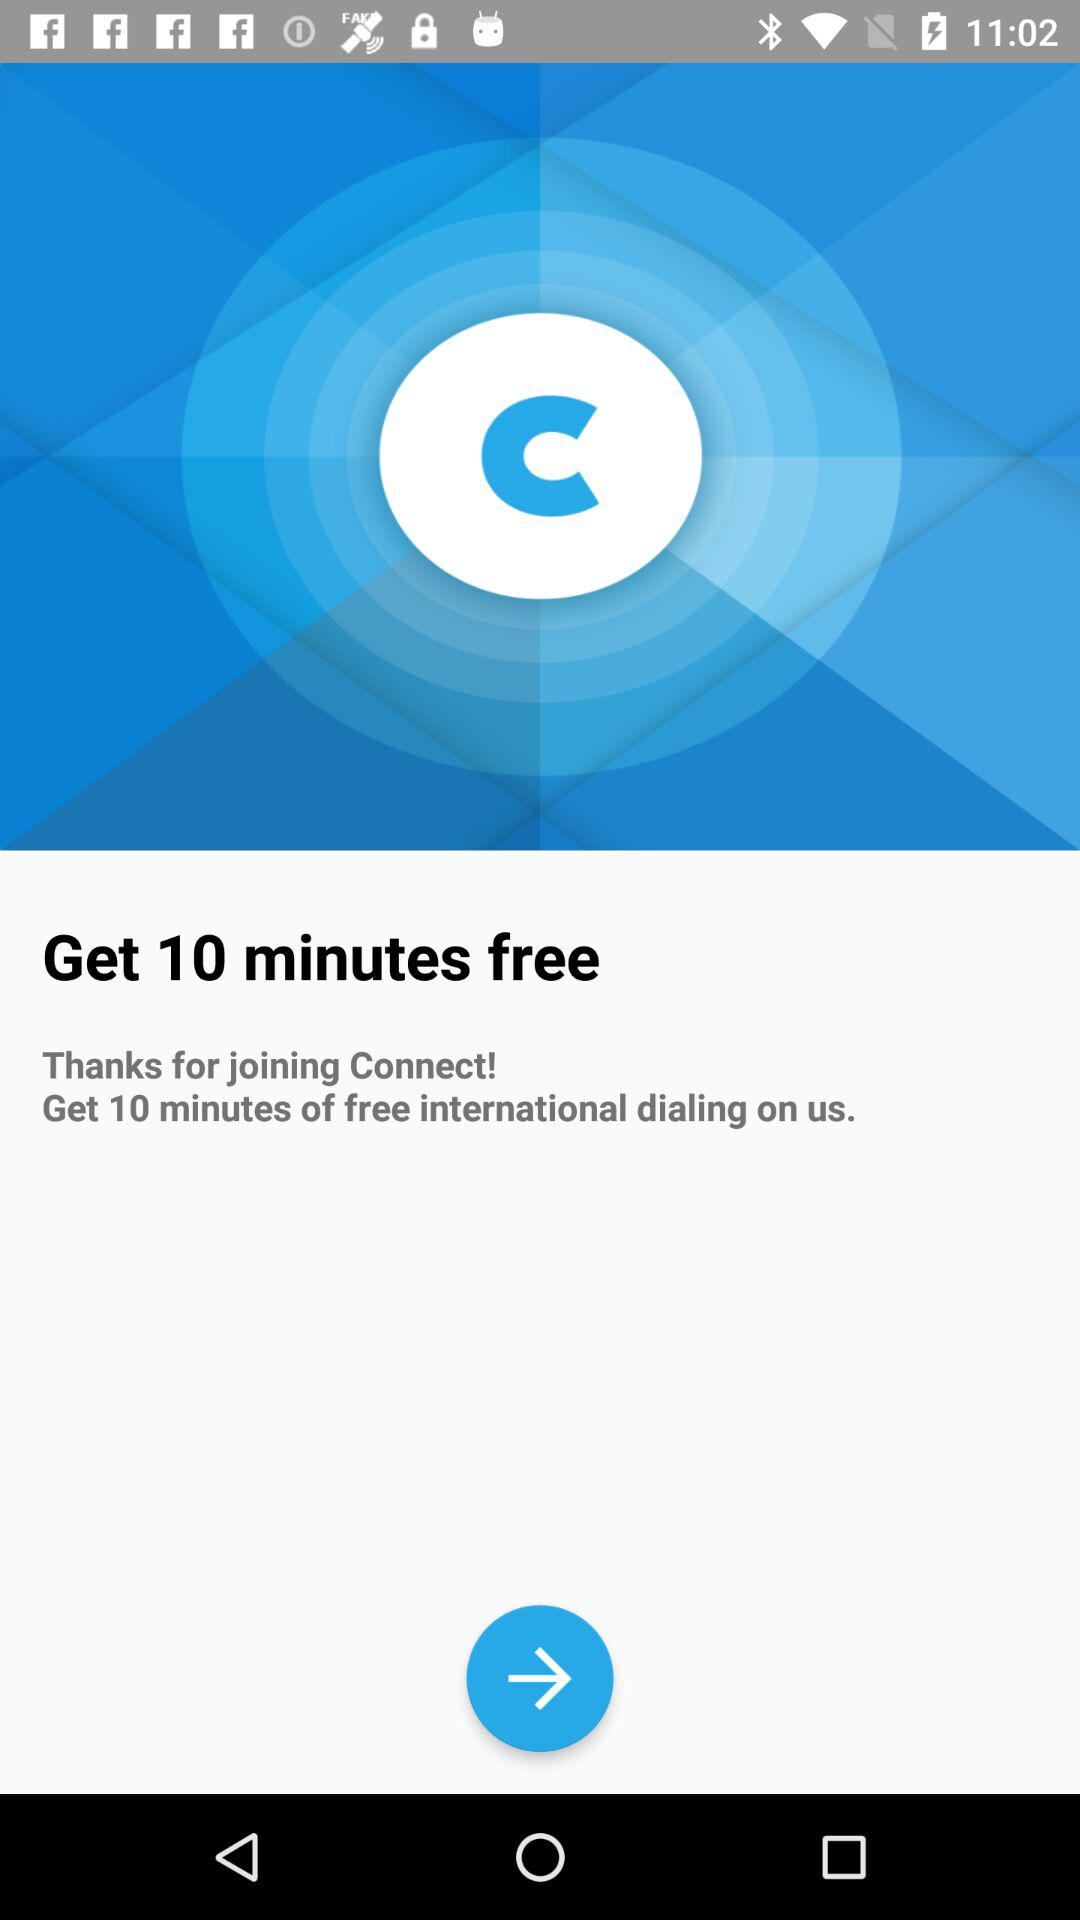How many minutes of free international dialing are there? There are 10 minutes of free international dialing. 